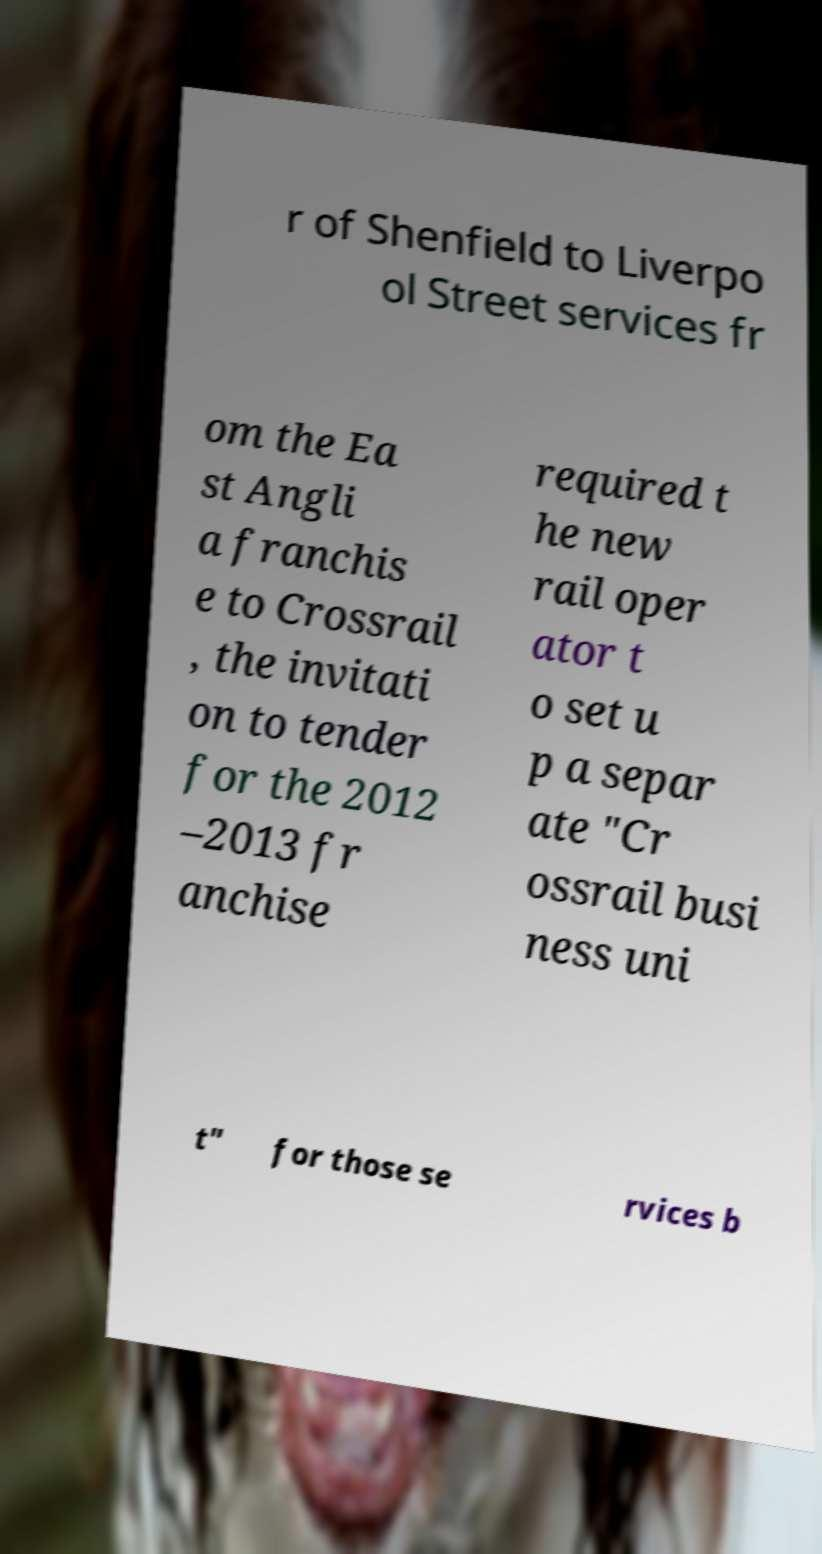For documentation purposes, I need the text within this image transcribed. Could you provide that? r of Shenfield to Liverpo ol Street services fr om the Ea st Angli a franchis e to Crossrail , the invitati on to tender for the 2012 –2013 fr anchise required t he new rail oper ator t o set u p a separ ate "Cr ossrail busi ness uni t" for those se rvices b 